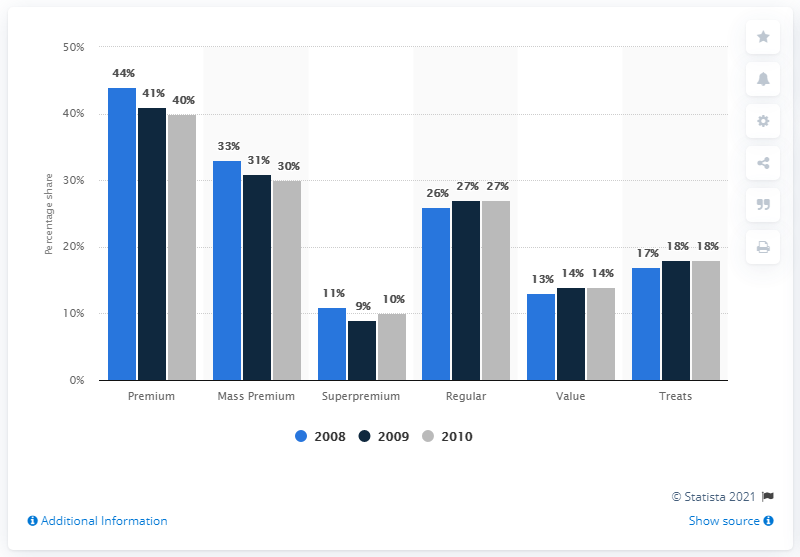Can you give me an analysis of the trend in premium dog and cat food sales over the years shown? Certainly! According to the image, there has been a slight decline in the premium category over the three years depicted. Sales percentages dropped from 44% in 2008 to 41% in 2009, and further to 40% in 2010, suggesting a downward trend in the premium segment's retail share during this time frame. 